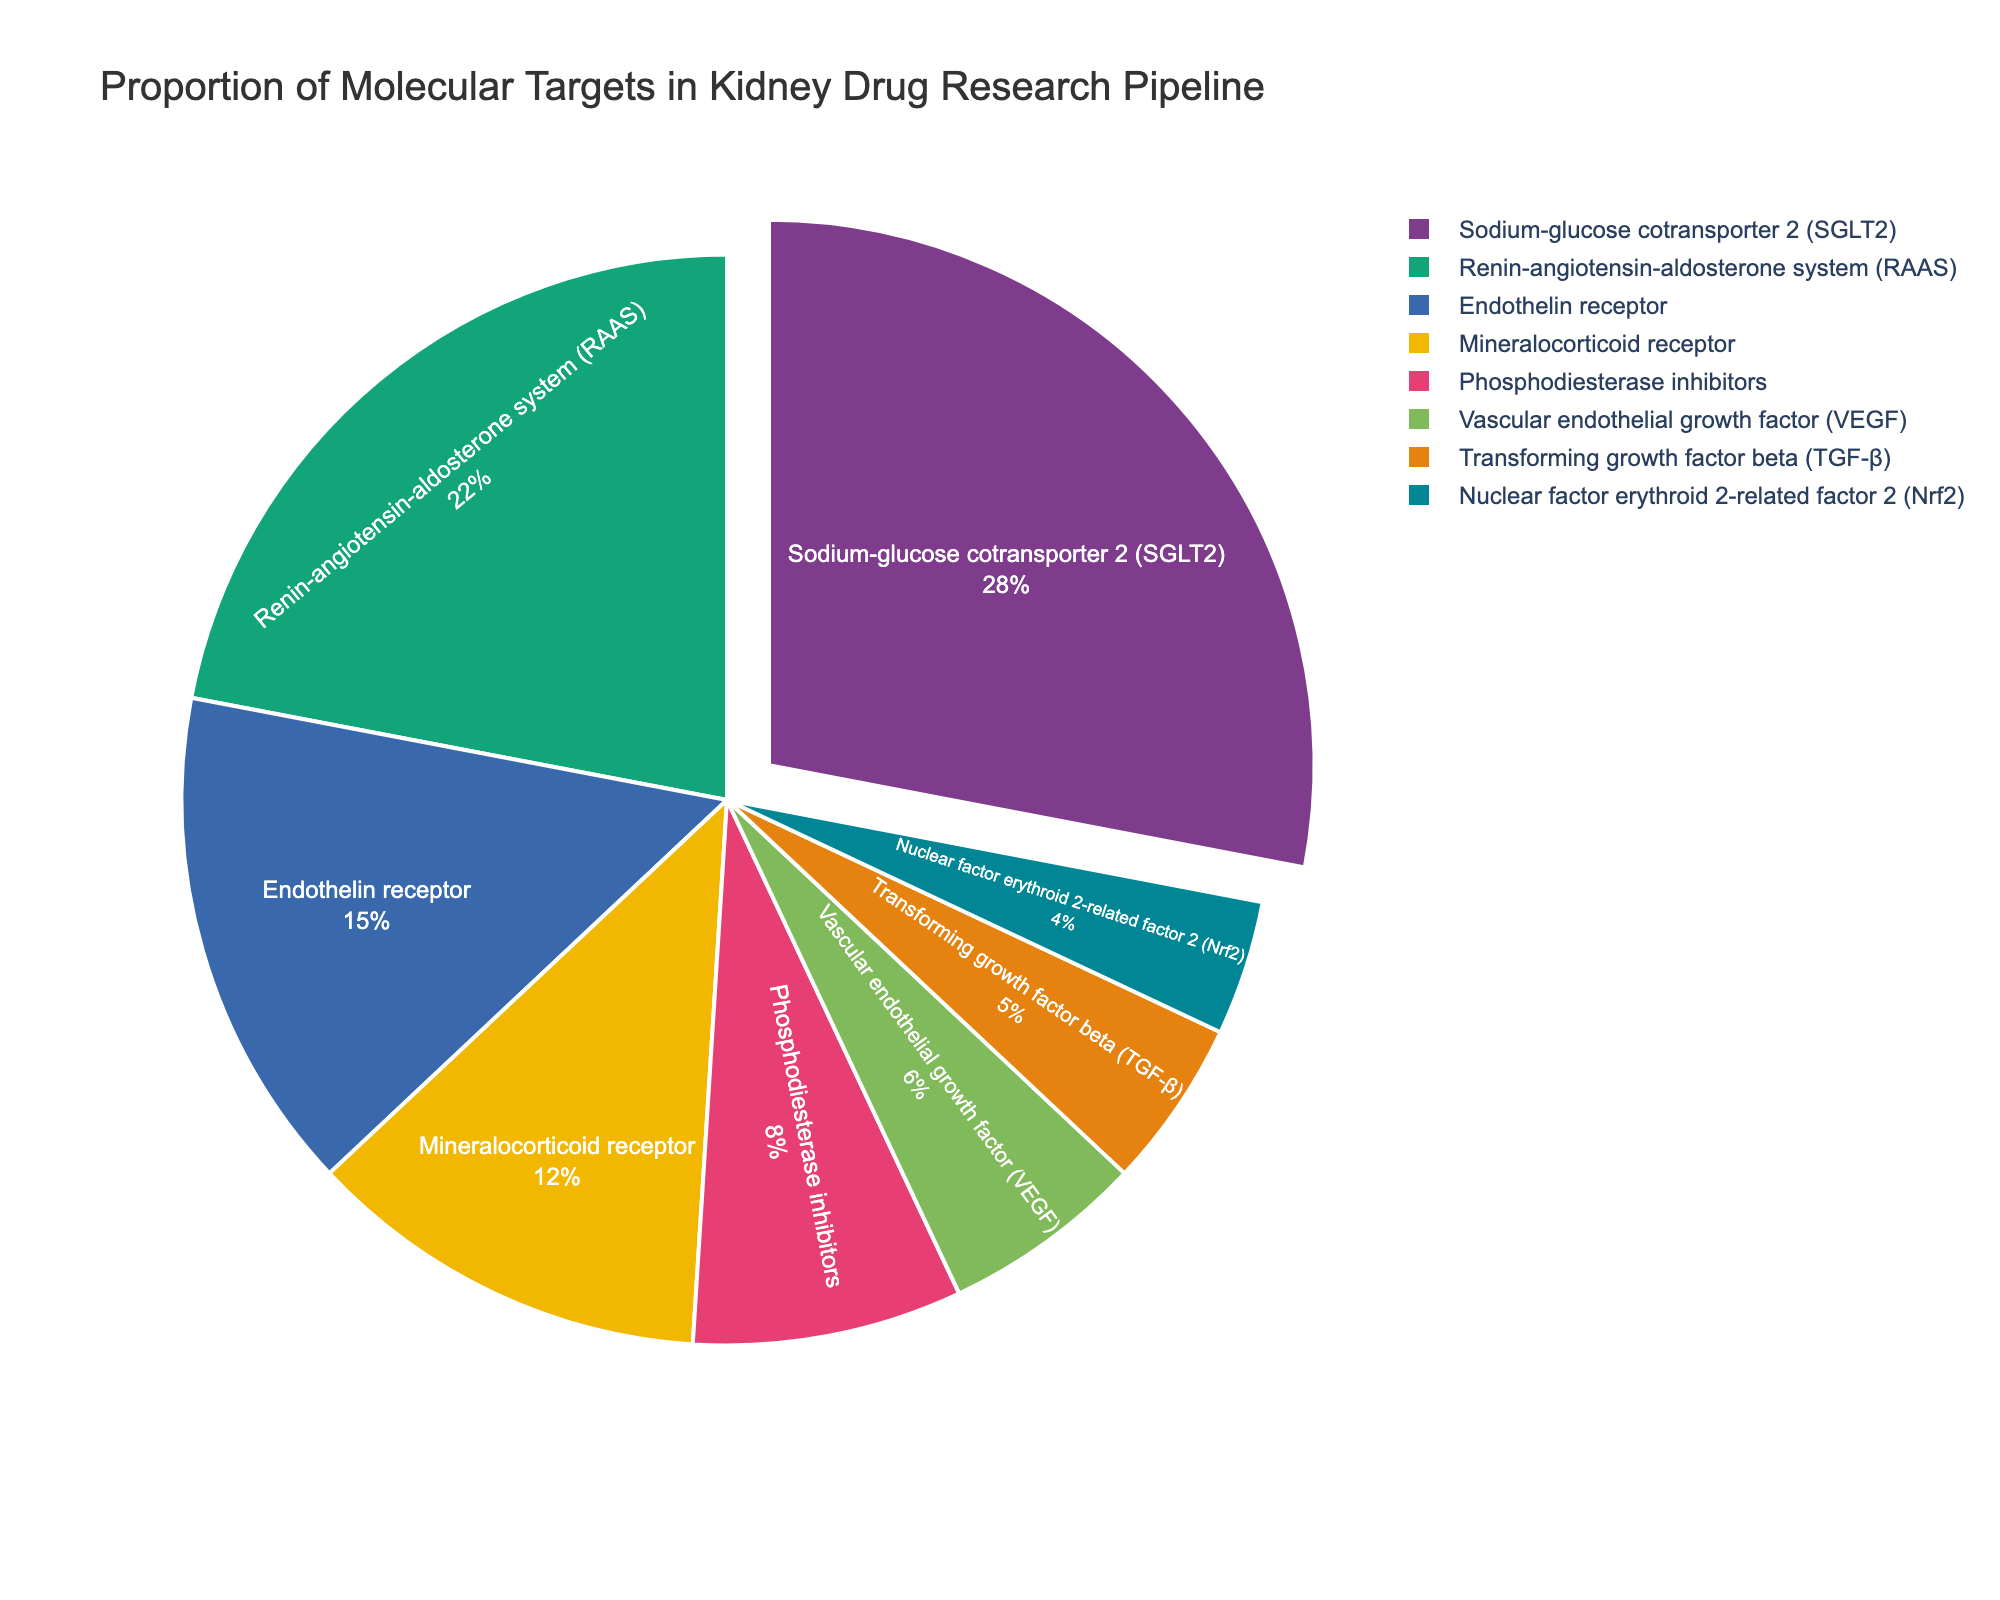What is the molecular target with the highest proportion in the kidney drug research pipeline? Looking at the pie chart, the segment representing "Sodium-glucose cotransporter 2 (SGLT2)" is the largest, indicating it has the highest percentage.
Answer: Sodium-glucose cotransporter 2 (SGLT2) Which two molecular targets together account for 50% of the research pipeline? The percentages of "Sodium-glucose cotransporter 2 (SGLT2)" and "Renin-angiotensin-aldosterone system (RAAS)" are 28% and 22%, respectively. Together, they sum to 50%.
Answer: Sodium-glucose cotransporter 2 (SGLT2) and Renin-angiotensin-aldosterone system (RAAS) How does the proportion of Endothelin receptor research compare to Mineralocorticoid receptor research? Endothelin receptor research accounts for 15% of the total while Mineralocorticoid receptor research is at 12%. The Endothelin receptor proportion is higher.
Answer: Endothelin receptor research is higher What is the combined percentage of Phosphodiesterase inhibitors and Vascular endothelial growth factor (VEGF) research? Phosphodiesterase inhibitors make up 8% and Vascular endothelial growth factor (VEGF) makes up 6%. Adding these together, the combined percentage is 14%.
Answer: 14% Which molecular target has the smallest proportion in the research pipeline and what is its percentage? The smallest segment on the pie chart represents "Nuclear factor erythroid 2-related factor 2 (Nrf2)," at 4%.
Answer: Nuclear factor erythroid 2-related factor 2 (Nrf2), 4% Arrange the molecular targets in descending order of their proportion in the research pipeline. From the pie chart, the order from largest to smallest proportion is: Sodium-glucose cotransporter 2 (SGLT2), Renin-angiotensin-aldosterone system (RAAS), Endothelin receptor, Mineralocorticoid receptor, Phosphodiesterase inhibitors, Vascular endothelial growth factor (VEGF), Transforming growth factor beta (TGF-β), Nuclear factor erythroid 2-related factor 2 (Nrf2).
Answer: SGLT2, RAAS, Endothelin receptor, Mineralocorticoid receptor, Phosphodiesterase inhibitors, VEGF, TGF-β, Nrf2 What percentage of the research pipeline is dedicated to targets other than the top two targets? The top two targets are SGLT2 and RAAS with percentages of 28% and 22%, totaling 50%. The percentage dedicated to other targets is 100% - 50% = 50%.
Answer: 50% How many more percentage points does SGLT2 have compared to Nrf2? SGLT2 is 28% and Nrf2 is 4%. The difference is 28% - 4% = 24%.
Answer: 24% Which segment appears to be pulled out from the pie chart and what could be the reason? The segment for "Sodium-glucose cotransporter 2 (SGLT2)" is pulled out, likely to highlight that it is the largest proportion.
Answer: Sodium-glucose cotransporter 2 (SGLT2) What is the total percentage of research focused on Endothelin receptor, Mineralocorticoid receptor, and Phosphodiesterase inhibitors combined? Adding these percentages from the chart: Endothelin receptor (15%) + Mineralocorticoid receptor (12%) + Phosphodiesterase inhibitors (8%) results in 35%.
Answer: 35% 